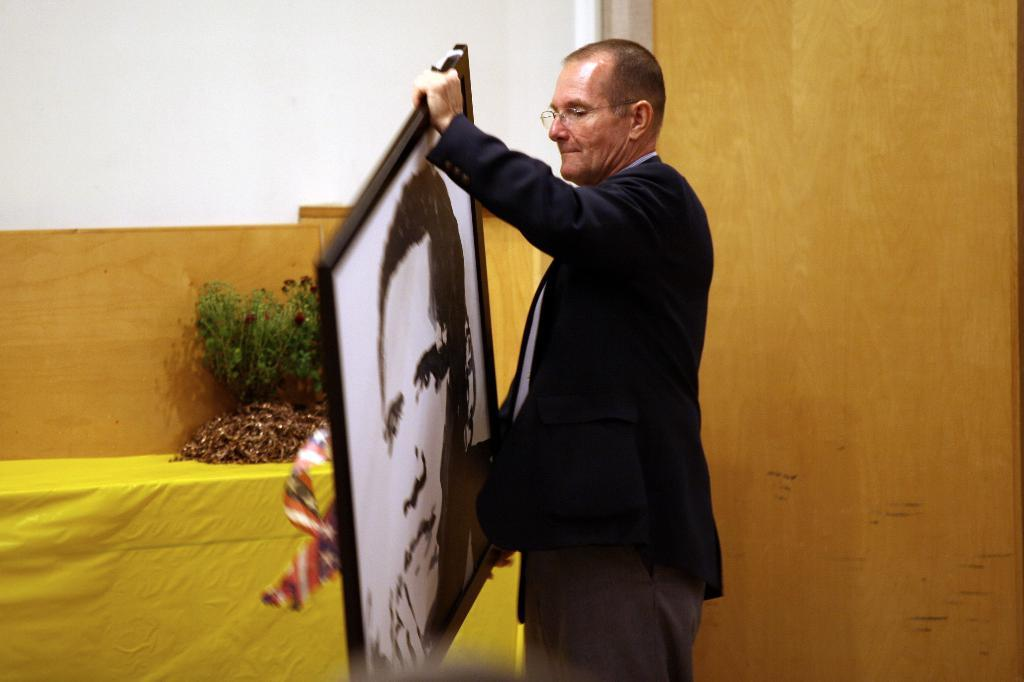Who is the main subject in the image? There is a man in the center of the image. What is the man doing in the image? The man is standing and holding a photo frame. What can be seen in the background of the image? There is a wall and a table in the background of the image. What is on the table in the background? There are plants on the table. What type of notebook is the man using to write in the image? There is no notebook present in the image; the man is holding a photo frame. Can you see the man skateboarding in the image? There is no skateboard or any indication of skateboarding in the image; the man is standing and holding a photo frame. 